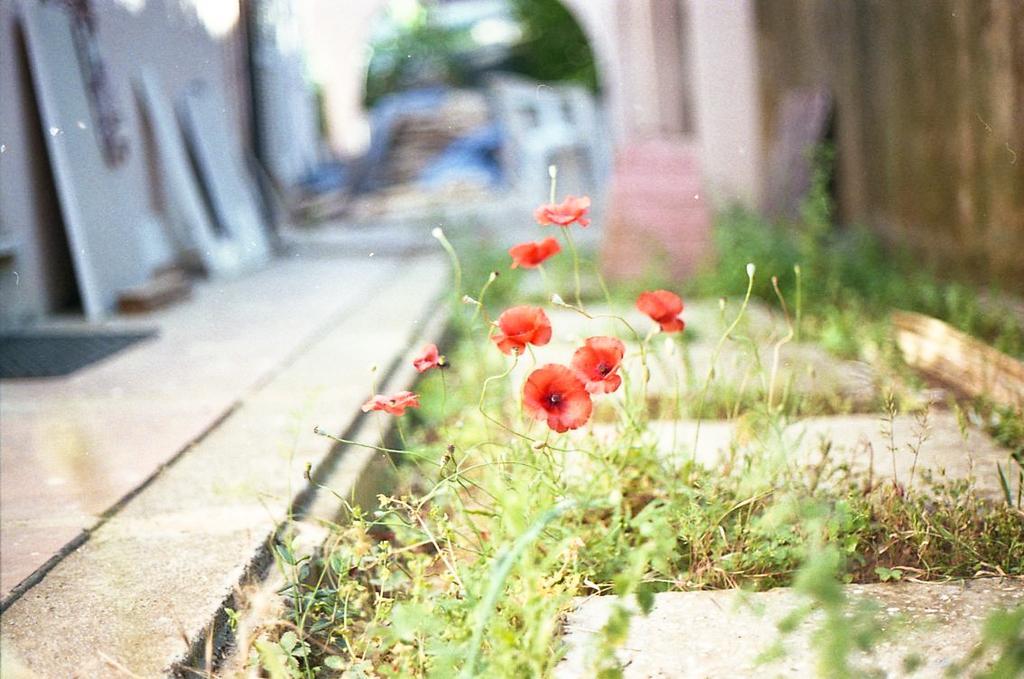Describe this image in one or two sentences. In this image I see the path over here and I see the plants and few flowers over here which are of red in color and I see that it is blurred in the background. 